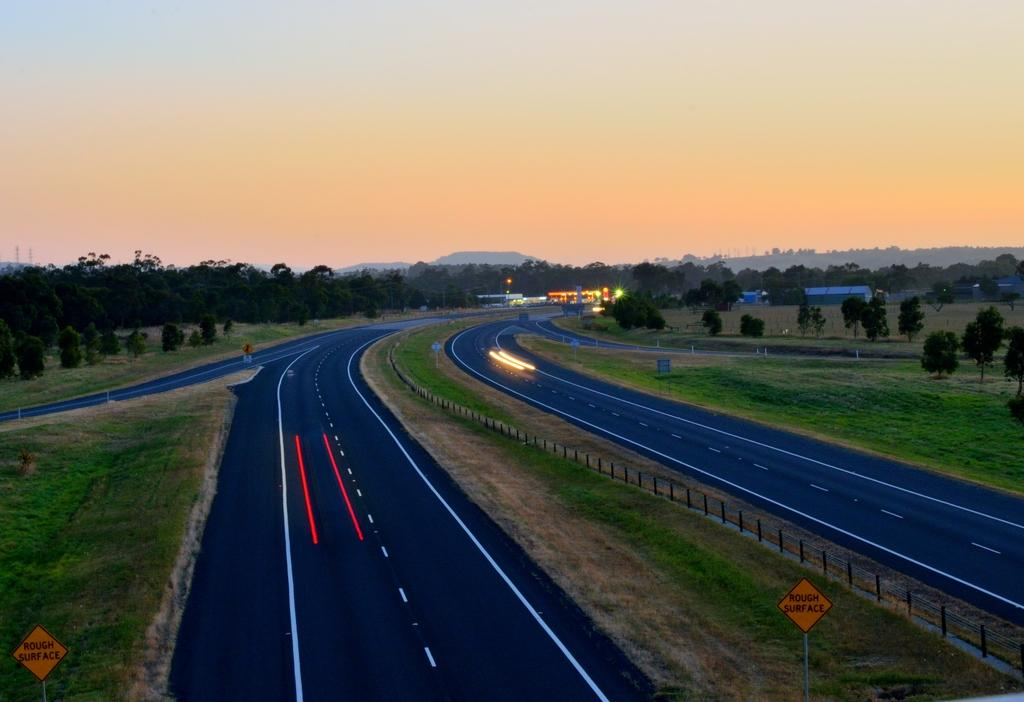What type of vegetation can be seen in the image? There is grass in the image. What type of signs are present in the image? There are name boards in the image. What type of pathways are visible in the image? There are roads in the image. What type of structures are present in the image? There are poles in the image. What type of barrier is present in the image? There is a fence in the image. What type of illumination is present in the image? There are lights in the image. What type of man-made structures are present in the image? There are buildings in the image. What type of natural elements are present in the image? There are trees in the image. What can be seen in the background of the image? The sky is visible in the background of the image. Where is the comb located in the image? There is no comb present in the image. What type of furniture is visible in the image? There is no table or person present in the image. 